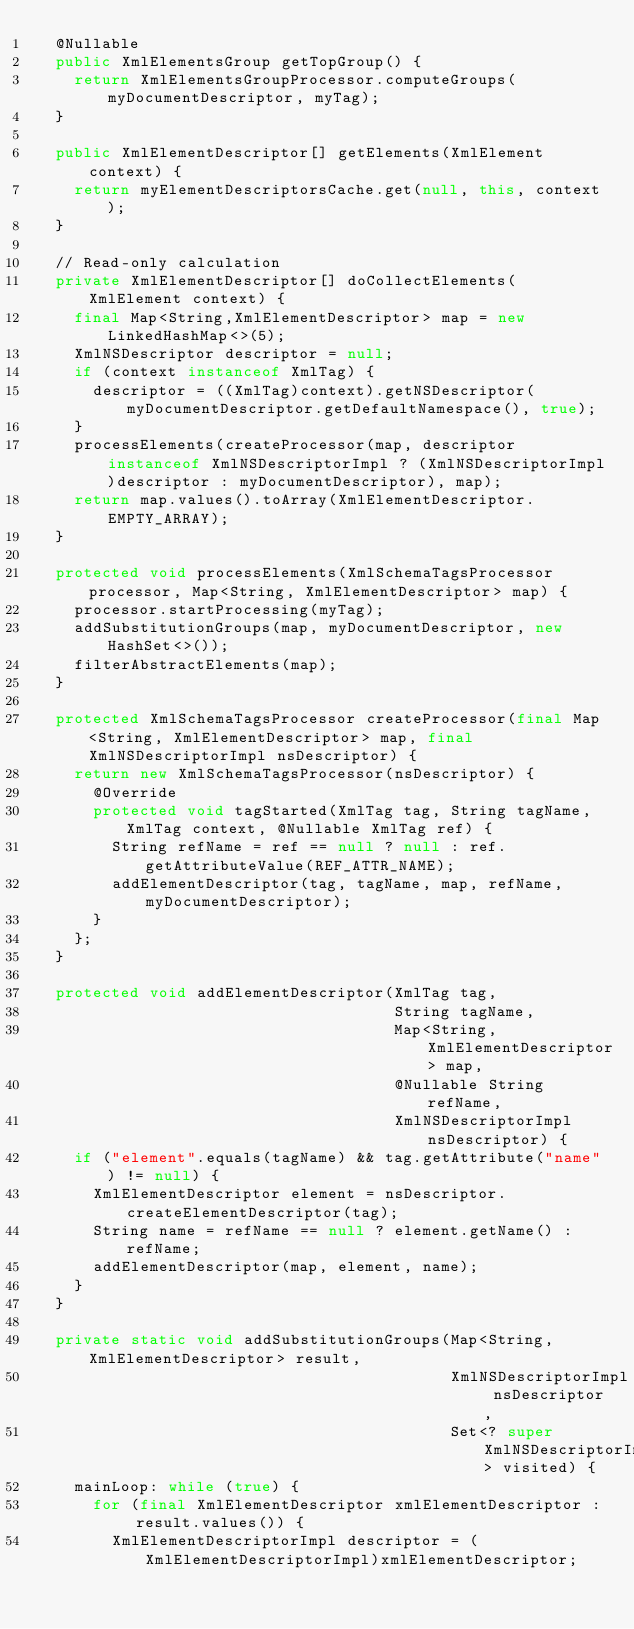Convert code to text. <code><loc_0><loc_0><loc_500><loc_500><_Java_>  @Nullable
  public XmlElementsGroup getTopGroup() {
    return XmlElementsGroupProcessor.computeGroups(myDocumentDescriptor, myTag);
  }

  public XmlElementDescriptor[] getElements(XmlElement context) {
    return myElementDescriptorsCache.get(null, this, context);
  }

  // Read-only calculation
  private XmlElementDescriptor[] doCollectElements(XmlElement context) {
    final Map<String,XmlElementDescriptor> map = new LinkedHashMap<>(5);
    XmlNSDescriptor descriptor = null;
    if (context instanceof XmlTag) {
      descriptor = ((XmlTag)context).getNSDescriptor(myDocumentDescriptor.getDefaultNamespace(), true);
    }
    processElements(createProcessor(map, descriptor instanceof XmlNSDescriptorImpl ? (XmlNSDescriptorImpl)descriptor : myDocumentDescriptor), map);
    return map.values().toArray(XmlElementDescriptor.EMPTY_ARRAY);
  }

  protected void processElements(XmlSchemaTagsProcessor processor, Map<String, XmlElementDescriptor> map) {
    processor.startProcessing(myTag);
    addSubstitutionGroups(map, myDocumentDescriptor, new HashSet<>());
    filterAbstractElements(map);
  }

  protected XmlSchemaTagsProcessor createProcessor(final Map<String, XmlElementDescriptor> map, final XmlNSDescriptorImpl nsDescriptor) {
    return new XmlSchemaTagsProcessor(nsDescriptor) {
      @Override
      protected void tagStarted(XmlTag tag, String tagName, XmlTag context, @Nullable XmlTag ref) {
        String refName = ref == null ? null : ref.getAttributeValue(REF_ATTR_NAME);
        addElementDescriptor(tag, tagName, map, refName, myDocumentDescriptor);
      }
    };
  }

  protected void addElementDescriptor(XmlTag tag,
                                      String tagName,
                                      Map<String, XmlElementDescriptor> map,
                                      @Nullable String refName,
                                      XmlNSDescriptorImpl nsDescriptor) {
    if ("element".equals(tagName) && tag.getAttribute("name") != null) {
      XmlElementDescriptor element = nsDescriptor.createElementDescriptor(tag);
      String name = refName == null ? element.getName() : refName;
      addElementDescriptor(map, element, name);
    }
  }

  private static void addSubstitutionGroups(Map<String, XmlElementDescriptor> result,
                                            XmlNSDescriptorImpl nsDescriptor,
                                            Set<? super XmlNSDescriptorImpl> visited) {
    mainLoop: while (true) {
      for (final XmlElementDescriptor xmlElementDescriptor : result.values()) {
        XmlElementDescriptorImpl descriptor = (XmlElementDescriptorImpl)xmlElementDescriptor;
</code> 